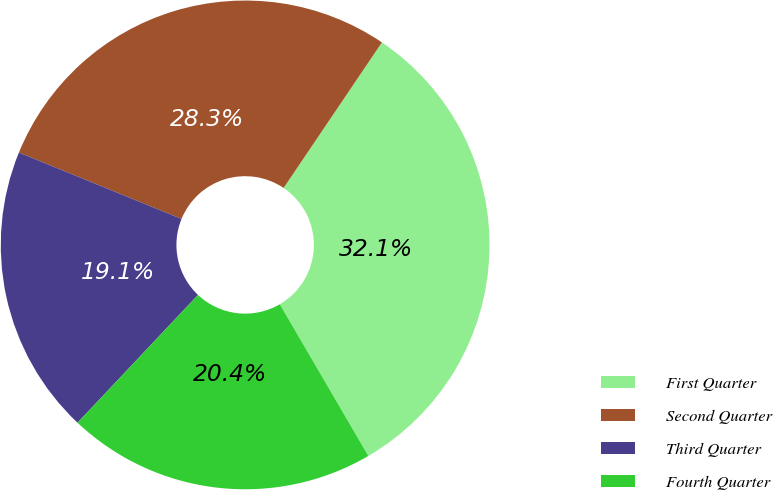Convert chart. <chart><loc_0><loc_0><loc_500><loc_500><pie_chart><fcel>First Quarter<fcel>Second Quarter<fcel>Third Quarter<fcel>Fourth Quarter<nl><fcel>32.14%<fcel>28.29%<fcel>19.14%<fcel>20.44%<nl></chart> 